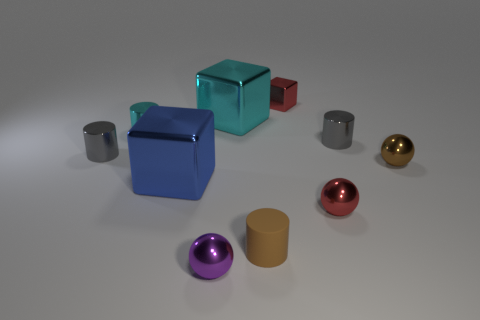There is a metal block that is on the left side of the tiny metal block and behind the small cyan cylinder; how big is it?
Give a very brief answer. Large. There is a cyan thing that is the same shape as the small brown rubber object; what is its size?
Provide a succinct answer. Small. How many objects are either large purple cubes or metal objects to the right of the brown cylinder?
Give a very brief answer. 4. What is the shape of the purple shiny thing?
Your response must be concise. Sphere. What shape is the red metallic thing that is in front of the brown object behind the blue block?
Provide a succinct answer. Sphere. There is a tiny ball that is the same color as the tiny block; what material is it?
Offer a terse response. Metal. There is a small block that is made of the same material as the big cyan cube; what color is it?
Offer a terse response. Red. Are there any other things that are the same size as the cyan cylinder?
Provide a succinct answer. Yes. Is the color of the small metallic ball to the right of the tiny red metallic ball the same as the big object that is behind the blue metallic object?
Offer a terse response. No. Is the number of small brown cylinders that are right of the rubber cylinder greater than the number of large cyan things in front of the tiny brown metallic object?
Offer a terse response. No. 